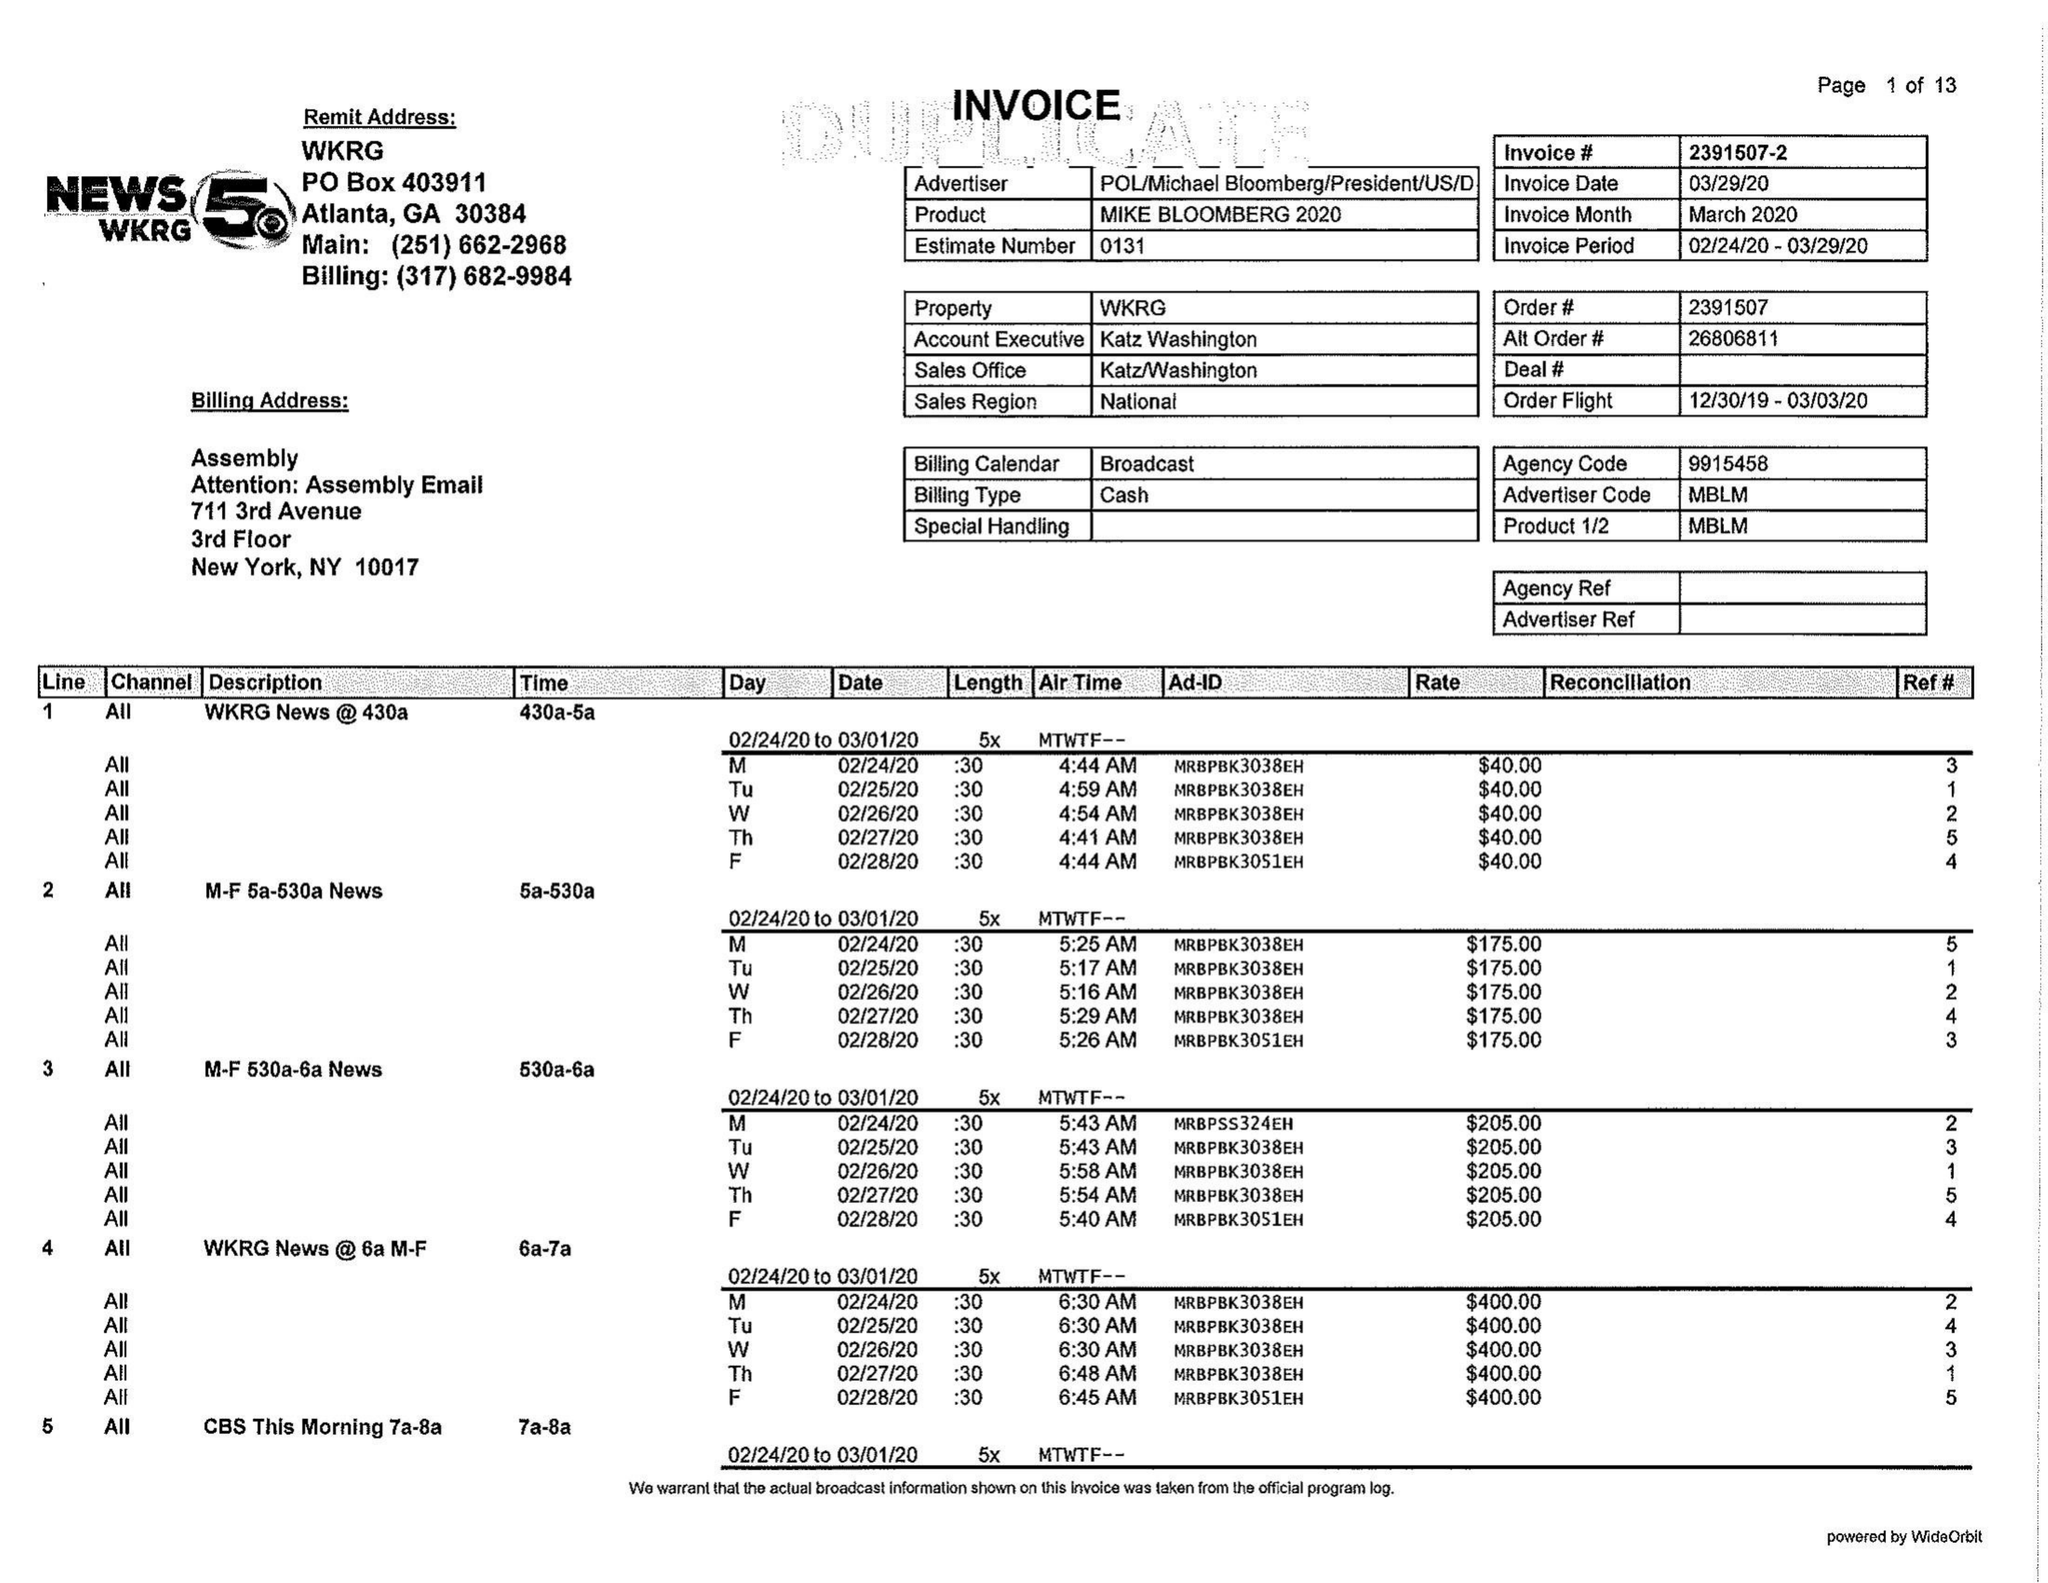What is the value for the flight_to?
Answer the question using a single word or phrase. 03/03/20 